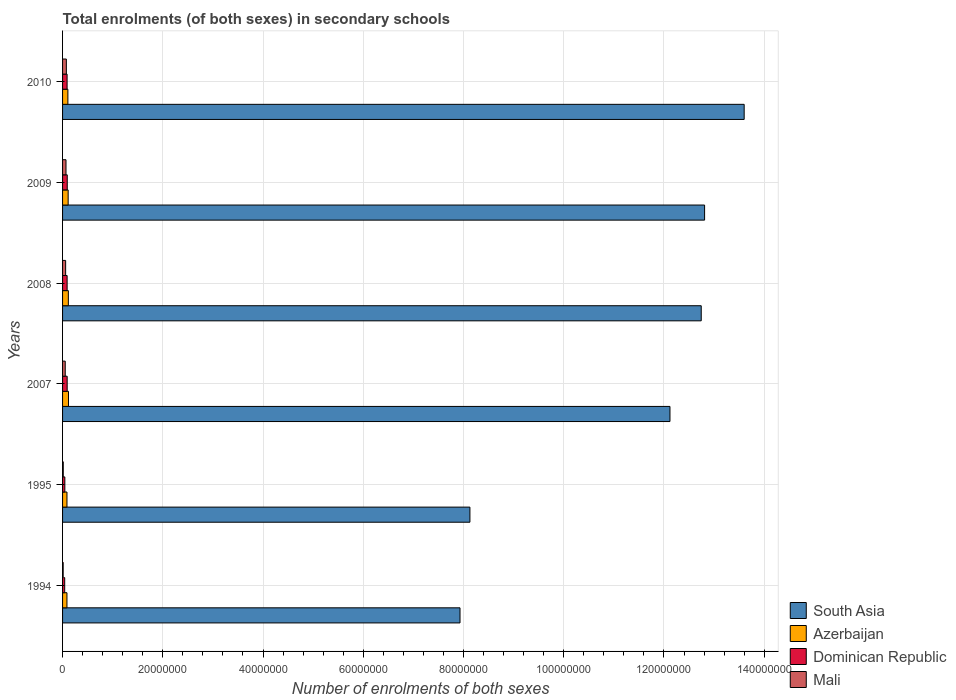Are the number of bars per tick equal to the number of legend labels?
Your response must be concise. Yes. How many bars are there on the 4th tick from the top?
Your answer should be compact. 4. What is the number of enrolments in secondary schools in Dominican Republic in 2009?
Provide a short and direct response. 9.34e+05. Across all years, what is the maximum number of enrolments in secondary schools in Azerbaijan?
Provide a short and direct response. 1.18e+06. Across all years, what is the minimum number of enrolments in secondary schools in South Asia?
Ensure brevity in your answer.  7.93e+07. In which year was the number of enrolments in secondary schools in Azerbaijan maximum?
Your answer should be very brief. 2007. What is the total number of enrolments in secondary schools in South Asia in the graph?
Give a very brief answer. 6.73e+08. What is the difference between the number of enrolments in secondary schools in South Asia in 1994 and that in 2008?
Provide a succinct answer. -4.81e+07. What is the difference between the number of enrolments in secondary schools in Azerbaijan in 2010 and the number of enrolments in secondary schools in South Asia in 2008?
Ensure brevity in your answer.  -1.26e+08. What is the average number of enrolments in secondary schools in South Asia per year?
Provide a succinct answer. 1.12e+08. In the year 1994, what is the difference between the number of enrolments in secondary schools in Azerbaijan and number of enrolments in secondary schools in Dominican Republic?
Ensure brevity in your answer.  4.49e+05. In how many years, is the number of enrolments in secondary schools in Mali greater than 120000000 ?
Provide a succinct answer. 0. What is the ratio of the number of enrolments in secondary schools in Dominican Republic in 1994 to that in 2008?
Provide a short and direct response. 0.47. Is the difference between the number of enrolments in secondary schools in Azerbaijan in 2007 and 2009 greater than the difference between the number of enrolments in secondary schools in Dominican Republic in 2007 and 2009?
Offer a terse response. Yes. What is the difference between the highest and the second highest number of enrolments in secondary schools in Dominican Republic?
Ensure brevity in your answer.  1.36e+04. What is the difference between the highest and the lowest number of enrolments in secondary schools in South Asia?
Offer a terse response. 5.67e+07. In how many years, is the number of enrolments in secondary schools in Dominican Republic greater than the average number of enrolments in secondary schools in Dominican Republic taken over all years?
Provide a short and direct response. 4. What does the 3rd bar from the top in 2009 represents?
Offer a very short reply. Azerbaijan. What does the 1st bar from the bottom in 2007 represents?
Offer a terse response. South Asia. Is it the case that in every year, the sum of the number of enrolments in secondary schools in South Asia and number of enrolments in secondary schools in Azerbaijan is greater than the number of enrolments in secondary schools in Mali?
Keep it short and to the point. Yes. Are all the bars in the graph horizontal?
Provide a short and direct response. Yes. How many years are there in the graph?
Your response must be concise. 6. What is the difference between two consecutive major ticks on the X-axis?
Offer a terse response. 2.00e+07. Are the values on the major ticks of X-axis written in scientific E-notation?
Ensure brevity in your answer.  No. Does the graph contain any zero values?
Make the answer very short. No. Where does the legend appear in the graph?
Ensure brevity in your answer.  Bottom right. What is the title of the graph?
Your answer should be very brief. Total enrolments (of both sexes) in secondary schools. Does "Japan" appear as one of the legend labels in the graph?
Make the answer very short. No. What is the label or title of the X-axis?
Your answer should be very brief. Number of enrolments of both sexes. What is the label or title of the Y-axis?
Provide a succinct answer. Years. What is the Number of enrolments of both sexes of South Asia in 1994?
Ensure brevity in your answer.  7.93e+07. What is the Number of enrolments of both sexes of Azerbaijan in 1994?
Give a very brief answer. 8.74e+05. What is the Number of enrolments of both sexes of Dominican Republic in 1994?
Your response must be concise. 4.25e+05. What is the Number of enrolments of both sexes of Mali in 1994?
Your response must be concise. 1.21e+05. What is the Number of enrolments of both sexes in South Asia in 1995?
Make the answer very short. 8.13e+07. What is the Number of enrolments of both sexes of Azerbaijan in 1995?
Make the answer very short. 8.78e+05. What is the Number of enrolments of both sexes of Dominican Republic in 1995?
Offer a terse response. 4.55e+05. What is the Number of enrolments of both sexes in Mali in 1995?
Offer a terse response. 1.40e+05. What is the Number of enrolments of both sexes of South Asia in 2007?
Offer a terse response. 1.21e+08. What is the Number of enrolments of both sexes in Azerbaijan in 2007?
Make the answer very short. 1.18e+06. What is the Number of enrolments of both sexes in Dominican Republic in 2007?
Keep it short and to the point. 9.20e+05. What is the Number of enrolments of both sexes of Mali in 2007?
Your answer should be very brief. 5.34e+05. What is the Number of enrolments of both sexes of South Asia in 2008?
Provide a succinct answer. 1.27e+08. What is the Number of enrolments of both sexes of Azerbaijan in 2008?
Provide a short and direct response. 1.15e+06. What is the Number of enrolments of both sexes of Dominican Republic in 2008?
Provide a succinct answer. 9.09e+05. What is the Number of enrolments of both sexes of Mali in 2008?
Your answer should be compact. 6.12e+05. What is the Number of enrolments of both sexes in South Asia in 2009?
Make the answer very short. 1.28e+08. What is the Number of enrolments of both sexes of Azerbaijan in 2009?
Provide a short and direct response. 1.11e+06. What is the Number of enrolments of both sexes in Dominican Republic in 2009?
Offer a very short reply. 9.34e+05. What is the Number of enrolments of both sexes of Mali in 2009?
Give a very brief answer. 6.86e+05. What is the Number of enrolments of both sexes in South Asia in 2010?
Provide a succinct answer. 1.36e+08. What is the Number of enrolments of both sexes of Azerbaijan in 2010?
Your response must be concise. 1.06e+06. What is the Number of enrolments of both sexes in Dominican Republic in 2010?
Offer a terse response. 9.05e+05. What is the Number of enrolments of both sexes of Mali in 2010?
Make the answer very short. 7.58e+05. Across all years, what is the maximum Number of enrolments of both sexes in South Asia?
Offer a very short reply. 1.36e+08. Across all years, what is the maximum Number of enrolments of both sexes of Azerbaijan?
Ensure brevity in your answer.  1.18e+06. Across all years, what is the maximum Number of enrolments of both sexes in Dominican Republic?
Give a very brief answer. 9.34e+05. Across all years, what is the maximum Number of enrolments of both sexes of Mali?
Provide a succinct answer. 7.58e+05. Across all years, what is the minimum Number of enrolments of both sexes in South Asia?
Give a very brief answer. 7.93e+07. Across all years, what is the minimum Number of enrolments of both sexes in Azerbaijan?
Keep it short and to the point. 8.74e+05. Across all years, what is the minimum Number of enrolments of both sexes in Dominican Republic?
Offer a very short reply. 4.25e+05. Across all years, what is the minimum Number of enrolments of both sexes of Mali?
Your answer should be compact. 1.21e+05. What is the total Number of enrolments of both sexes in South Asia in the graph?
Provide a succinct answer. 6.73e+08. What is the total Number of enrolments of both sexes in Azerbaijan in the graph?
Make the answer very short. 6.26e+06. What is the total Number of enrolments of both sexes of Dominican Republic in the graph?
Offer a very short reply. 4.55e+06. What is the total Number of enrolments of both sexes of Mali in the graph?
Provide a short and direct response. 2.85e+06. What is the difference between the Number of enrolments of both sexes of South Asia in 1994 and that in 1995?
Offer a terse response. -1.98e+06. What is the difference between the Number of enrolments of both sexes of Azerbaijan in 1994 and that in 1995?
Offer a terse response. -3873. What is the difference between the Number of enrolments of both sexes in Dominican Republic in 1994 and that in 1995?
Keep it short and to the point. -2.93e+04. What is the difference between the Number of enrolments of both sexes of Mali in 1994 and that in 1995?
Provide a succinct answer. -1.89e+04. What is the difference between the Number of enrolments of both sexes of South Asia in 1994 and that in 2007?
Ensure brevity in your answer.  -4.19e+07. What is the difference between the Number of enrolments of both sexes of Azerbaijan in 1994 and that in 2007?
Give a very brief answer. -3.07e+05. What is the difference between the Number of enrolments of both sexes in Dominican Republic in 1994 and that in 2007?
Make the answer very short. -4.95e+05. What is the difference between the Number of enrolments of both sexes in Mali in 1994 and that in 2007?
Your answer should be very brief. -4.13e+05. What is the difference between the Number of enrolments of both sexes of South Asia in 1994 and that in 2008?
Give a very brief answer. -4.81e+07. What is the difference between the Number of enrolments of both sexes of Azerbaijan in 1994 and that in 2008?
Ensure brevity in your answer.  -2.77e+05. What is the difference between the Number of enrolments of both sexes in Dominican Republic in 1994 and that in 2008?
Your answer should be very brief. -4.84e+05. What is the difference between the Number of enrolments of both sexes of Mali in 1994 and that in 2008?
Keep it short and to the point. -4.91e+05. What is the difference between the Number of enrolments of both sexes in South Asia in 1994 and that in 2009?
Keep it short and to the point. -4.88e+07. What is the difference between the Number of enrolments of both sexes of Azerbaijan in 1994 and that in 2009?
Your answer should be very brief. -2.40e+05. What is the difference between the Number of enrolments of both sexes of Dominican Republic in 1994 and that in 2009?
Offer a terse response. -5.09e+05. What is the difference between the Number of enrolments of both sexes in Mali in 1994 and that in 2009?
Keep it short and to the point. -5.65e+05. What is the difference between the Number of enrolments of both sexes in South Asia in 1994 and that in 2010?
Ensure brevity in your answer.  -5.67e+07. What is the difference between the Number of enrolments of both sexes of Azerbaijan in 1994 and that in 2010?
Make the answer very short. -1.89e+05. What is the difference between the Number of enrolments of both sexes of Dominican Republic in 1994 and that in 2010?
Your response must be concise. -4.79e+05. What is the difference between the Number of enrolments of both sexes in Mali in 1994 and that in 2010?
Your response must be concise. -6.37e+05. What is the difference between the Number of enrolments of both sexes in South Asia in 1995 and that in 2007?
Your answer should be compact. -3.99e+07. What is the difference between the Number of enrolments of both sexes of Azerbaijan in 1995 and that in 2007?
Your response must be concise. -3.04e+05. What is the difference between the Number of enrolments of both sexes in Dominican Republic in 1995 and that in 2007?
Ensure brevity in your answer.  -4.66e+05. What is the difference between the Number of enrolments of both sexes in Mali in 1995 and that in 2007?
Keep it short and to the point. -3.94e+05. What is the difference between the Number of enrolments of both sexes in South Asia in 1995 and that in 2008?
Your response must be concise. -4.62e+07. What is the difference between the Number of enrolments of both sexes in Azerbaijan in 1995 and that in 2008?
Make the answer very short. -2.74e+05. What is the difference between the Number of enrolments of both sexes in Dominican Republic in 1995 and that in 2008?
Ensure brevity in your answer.  -4.55e+05. What is the difference between the Number of enrolments of both sexes in Mali in 1995 and that in 2008?
Make the answer very short. -4.72e+05. What is the difference between the Number of enrolments of both sexes of South Asia in 1995 and that in 2009?
Your answer should be compact. -4.68e+07. What is the difference between the Number of enrolments of both sexes in Azerbaijan in 1995 and that in 2009?
Your response must be concise. -2.37e+05. What is the difference between the Number of enrolments of both sexes in Dominican Republic in 1995 and that in 2009?
Your answer should be very brief. -4.80e+05. What is the difference between the Number of enrolments of both sexes in Mali in 1995 and that in 2009?
Your answer should be compact. -5.46e+05. What is the difference between the Number of enrolments of both sexes in South Asia in 1995 and that in 2010?
Your answer should be very brief. -5.47e+07. What is the difference between the Number of enrolments of both sexes in Azerbaijan in 1995 and that in 2010?
Offer a terse response. -1.85e+05. What is the difference between the Number of enrolments of both sexes of Dominican Republic in 1995 and that in 2010?
Ensure brevity in your answer.  -4.50e+05. What is the difference between the Number of enrolments of both sexes of Mali in 1995 and that in 2010?
Ensure brevity in your answer.  -6.19e+05. What is the difference between the Number of enrolments of both sexes of South Asia in 2007 and that in 2008?
Keep it short and to the point. -6.24e+06. What is the difference between the Number of enrolments of both sexes of Azerbaijan in 2007 and that in 2008?
Your answer should be very brief. 3.00e+04. What is the difference between the Number of enrolments of both sexes in Dominican Republic in 2007 and that in 2008?
Your response must be concise. 1.12e+04. What is the difference between the Number of enrolments of both sexes in Mali in 2007 and that in 2008?
Make the answer very short. -7.82e+04. What is the difference between the Number of enrolments of both sexes in South Asia in 2007 and that in 2009?
Your answer should be compact. -6.91e+06. What is the difference between the Number of enrolments of both sexes of Azerbaijan in 2007 and that in 2009?
Your response must be concise. 6.70e+04. What is the difference between the Number of enrolments of both sexes of Dominican Republic in 2007 and that in 2009?
Make the answer very short. -1.36e+04. What is the difference between the Number of enrolments of both sexes in Mali in 2007 and that in 2009?
Keep it short and to the point. -1.52e+05. What is the difference between the Number of enrolments of both sexes in South Asia in 2007 and that in 2010?
Make the answer very short. -1.48e+07. What is the difference between the Number of enrolments of both sexes in Azerbaijan in 2007 and that in 2010?
Give a very brief answer. 1.19e+05. What is the difference between the Number of enrolments of both sexes in Dominican Republic in 2007 and that in 2010?
Your response must be concise. 1.60e+04. What is the difference between the Number of enrolments of both sexes in Mali in 2007 and that in 2010?
Give a very brief answer. -2.24e+05. What is the difference between the Number of enrolments of both sexes in South Asia in 2008 and that in 2009?
Keep it short and to the point. -6.70e+05. What is the difference between the Number of enrolments of both sexes in Azerbaijan in 2008 and that in 2009?
Ensure brevity in your answer.  3.70e+04. What is the difference between the Number of enrolments of both sexes of Dominican Republic in 2008 and that in 2009?
Keep it short and to the point. -2.48e+04. What is the difference between the Number of enrolments of both sexes of Mali in 2008 and that in 2009?
Give a very brief answer. -7.41e+04. What is the difference between the Number of enrolments of both sexes of South Asia in 2008 and that in 2010?
Make the answer very short. -8.57e+06. What is the difference between the Number of enrolments of both sexes of Azerbaijan in 2008 and that in 2010?
Give a very brief answer. 8.87e+04. What is the difference between the Number of enrolments of both sexes in Dominican Republic in 2008 and that in 2010?
Offer a very short reply. 4804. What is the difference between the Number of enrolments of both sexes of Mali in 2008 and that in 2010?
Your response must be concise. -1.46e+05. What is the difference between the Number of enrolments of both sexes in South Asia in 2009 and that in 2010?
Your answer should be compact. -7.90e+06. What is the difference between the Number of enrolments of both sexes in Azerbaijan in 2009 and that in 2010?
Your answer should be compact. 5.17e+04. What is the difference between the Number of enrolments of both sexes in Dominican Republic in 2009 and that in 2010?
Provide a succinct answer. 2.96e+04. What is the difference between the Number of enrolments of both sexes in Mali in 2009 and that in 2010?
Offer a terse response. -7.22e+04. What is the difference between the Number of enrolments of both sexes in South Asia in 1994 and the Number of enrolments of both sexes in Azerbaijan in 1995?
Your answer should be very brief. 7.84e+07. What is the difference between the Number of enrolments of both sexes of South Asia in 1994 and the Number of enrolments of both sexes of Dominican Republic in 1995?
Your answer should be compact. 7.88e+07. What is the difference between the Number of enrolments of both sexes of South Asia in 1994 and the Number of enrolments of both sexes of Mali in 1995?
Offer a terse response. 7.92e+07. What is the difference between the Number of enrolments of both sexes of Azerbaijan in 1994 and the Number of enrolments of both sexes of Dominican Republic in 1995?
Offer a terse response. 4.19e+05. What is the difference between the Number of enrolments of both sexes of Azerbaijan in 1994 and the Number of enrolments of both sexes of Mali in 1995?
Keep it short and to the point. 7.34e+05. What is the difference between the Number of enrolments of both sexes of Dominican Republic in 1994 and the Number of enrolments of both sexes of Mali in 1995?
Ensure brevity in your answer.  2.85e+05. What is the difference between the Number of enrolments of both sexes of South Asia in 1994 and the Number of enrolments of both sexes of Azerbaijan in 2007?
Your answer should be compact. 7.81e+07. What is the difference between the Number of enrolments of both sexes in South Asia in 1994 and the Number of enrolments of both sexes in Dominican Republic in 2007?
Give a very brief answer. 7.84e+07. What is the difference between the Number of enrolments of both sexes in South Asia in 1994 and the Number of enrolments of both sexes in Mali in 2007?
Keep it short and to the point. 7.88e+07. What is the difference between the Number of enrolments of both sexes of Azerbaijan in 1994 and the Number of enrolments of both sexes of Dominican Republic in 2007?
Your answer should be very brief. -4.66e+04. What is the difference between the Number of enrolments of both sexes in Azerbaijan in 1994 and the Number of enrolments of both sexes in Mali in 2007?
Your answer should be compact. 3.40e+05. What is the difference between the Number of enrolments of both sexes in Dominican Republic in 1994 and the Number of enrolments of both sexes in Mali in 2007?
Ensure brevity in your answer.  -1.09e+05. What is the difference between the Number of enrolments of both sexes in South Asia in 1994 and the Number of enrolments of both sexes in Azerbaijan in 2008?
Your answer should be compact. 7.82e+07. What is the difference between the Number of enrolments of both sexes of South Asia in 1994 and the Number of enrolments of both sexes of Dominican Republic in 2008?
Your answer should be very brief. 7.84e+07. What is the difference between the Number of enrolments of both sexes in South Asia in 1994 and the Number of enrolments of both sexes in Mali in 2008?
Your response must be concise. 7.87e+07. What is the difference between the Number of enrolments of both sexes of Azerbaijan in 1994 and the Number of enrolments of both sexes of Dominican Republic in 2008?
Provide a succinct answer. -3.54e+04. What is the difference between the Number of enrolments of both sexes in Azerbaijan in 1994 and the Number of enrolments of both sexes in Mali in 2008?
Your answer should be compact. 2.62e+05. What is the difference between the Number of enrolments of both sexes of Dominican Republic in 1994 and the Number of enrolments of both sexes of Mali in 2008?
Ensure brevity in your answer.  -1.87e+05. What is the difference between the Number of enrolments of both sexes of South Asia in 1994 and the Number of enrolments of both sexes of Azerbaijan in 2009?
Provide a short and direct response. 7.82e+07. What is the difference between the Number of enrolments of both sexes of South Asia in 1994 and the Number of enrolments of both sexes of Dominican Republic in 2009?
Keep it short and to the point. 7.84e+07. What is the difference between the Number of enrolments of both sexes of South Asia in 1994 and the Number of enrolments of both sexes of Mali in 2009?
Your answer should be compact. 7.86e+07. What is the difference between the Number of enrolments of both sexes in Azerbaijan in 1994 and the Number of enrolments of both sexes in Dominican Republic in 2009?
Your answer should be compact. -6.02e+04. What is the difference between the Number of enrolments of both sexes in Azerbaijan in 1994 and the Number of enrolments of both sexes in Mali in 2009?
Your response must be concise. 1.88e+05. What is the difference between the Number of enrolments of both sexes in Dominican Republic in 1994 and the Number of enrolments of both sexes in Mali in 2009?
Keep it short and to the point. -2.61e+05. What is the difference between the Number of enrolments of both sexes in South Asia in 1994 and the Number of enrolments of both sexes in Azerbaijan in 2010?
Keep it short and to the point. 7.82e+07. What is the difference between the Number of enrolments of both sexes in South Asia in 1994 and the Number of enrolments of both sexes in Dominican Republic in 2010?
Offer a very short reply. 7.84e+07. What is the difference between the Number of enrolments of both sexes in South Asia in 1994 and the Number of enrolments of both sexes in Mali in 2010?
Ensure brevity in your answer.  7.85e+07. What is the difference between the Number of enrolments of both sexes in Azerbaijan in 1994 and the Number of enrolments of both sexes in Dominican Republic in 2010?
Keep it short and to the point. -3.06e+04. What is the difference between the Number of enrolments of both sexes in Azerbaijan in 1994 and the Number of enrolments of both sexes in Mali in 2010?
Offer a very short reply. 1.16e+05. What is the difference between the Number of enrolments of both sexes of Dominican Republic in 1994 and the Number of enrolments of both sexes of Mali in 2010?
Keep it short and to the point. -3.33e+05. What is the difference between the Number of enrolments of both sexes in South Asia in 1995 and the Number of enrolments of both sexes in Azerbaijan in 2007?
Your answer should be compact. 8.01e+07. What is the difference between the Number of enrolments of both sexes in South Asia in 1995 and the Number of enrolments of both sexes in Dominican Republic in 2007?
Your answer should be compact. 8.04e+07. What is the difference between the Number of enrolments of both sexes in South Asia in 1995 and the Number of enrolments of both sexes in Mali in 2007?
Make the answer very short. 8.07e+07. What is the difference between the Number of enrolments of both sexes in Azerbaijan in 1995 and the Number of enrolments of both sexes in Dominican Republic in 2007?
Provide a succinct answer. -4.27e+04. What is the difference between the Number of enrolments of both sexes in Azerbaijan in 1995 and the Number of enrolments of both sexes in Mali in 2007?
Your answer should be very brief. 3.44e+05. What is the difference between the Number of enrolments of both sexes of Dominican Republic in 1995 and the Number of enrolments of both sexes of Mali in 2007?
Ensure brevity in your answer.  -7.93e+04. What is the difference between the Number of enrolments of both sexes of South Asia in 1995 and the Number of enrolments of both sexes of Azerbaijan in 2008?
Your answer should be very brief. 8.01e+07. What is the difference between the Number of enrolments of both sexes in South Asia in 1995 and the Number of enrolments of both sexes in Dominican Republic in 2008?
Offer a terse response. 8.04e+07. What is the difference between the Number of enrolments of both sexes in South Asia in 1995 and the Number of enrolments of both sexes in Mali in 2008?
Offer a very short reply. 8.07e+07. What is the difference between the Number of enrolments of both sexes of Azerbaijan in 1995 and the Number of enrolments of both sexes of Dominican Republic in 2008?
Make the answer very short. -3.15e+04. What is the difference between the Number of enrolments of both sexes of Azerbaijan in 1995 and the Number of enrolments of both sexes of Mali in 2008?
Your answer should be compact. 2.66e+05. What is the difference between the Number of enrolments of both sexes of Dominican Republic in 1995 and the Number of enrolments of both sexes of Mali in 2008?
Your answer should be very brief. -1.57e+05. What is the difference between the Number of enrolments of both sexes in South Asia in 1995 and the Number of enrolments of both sexes in Azerbaijan in 2009?
Keep it short and to the point. 8.02e+07. What is the difference between the Number of enrolments of both sexes in South Asia in 1995 and the Number of enrolments of both sexes in Dominican Republic in 2009?
Ensure brevity in your answer.  8.03e+07. What is the difference between the Number of enrolments of both sexes in South Asia in 1995 and the Number of enrolments of both sexes in Mali in 2009?
Make the answer very short. 8.06e+07. What is the difference between the Number of enrolments of both sexes of Azerbaijan in 1995 and the Number of enrolments of both sexes of Dominican Republic in 2009?
Your answer should be compact. -5.63e+04. What is the difference between the Number of enrolments of both sexes of Azerbaijan in 1995 and the Number of enrolments of both sexes of Mali in 2009?
Ensure brevity in your answer.  1.92e+05. What is the difference between the Number of enrolments of both sexes of Dominican Republic in 1995 and the Number of enrolments of both sexes of Mali in 2009?
Your response must be concise. -2.32e+05. What is the difference between the Number of enrolments of both sexes of South Asia in 1995 and the Number of enrolments of both sexes of Azerbaijan in 2010?
Provide a short and direct response. 8.02e+07. What is the difference between the Number of enrolments of both sexes of South Asia in 1995 and the Number of enrolments of both sexes of Dominican Republic in 2010?
Make the answer very short. 8.04e+07. What is the difference between the Number of enrolments of both sexes of South Asia in 1995 and the Number of enrolments of both sexes of Mali in 2010?
Keep it short and to the point. 8.05e+07. What is the difference between the Number of enrolments of both sexes of Azerbaijan in 1995 and the Number of enrolments of both sexes of Dominican Republic in 2010?
Offer a very short reply. -2.67e+04. What is the difference between the Number of enrolments of both sexes in Azerbaijan in 1995 and the Number of enrolments of both sexes in Mali in 2010?
Your response must be concise. 1.20e+05. What is the difference between the Number of enrolments of both sexes in Dominican Republic in 1995 and the Number of enrolments of both sexes in Mali in 2010?
Your response must be concise. -3.04e+05. What is the difference between the Number of enrolments of both sexes of South Asia in 2007 and the Number of enrolments of both sexes of Azerbaijan in 2008?
Ensure brevity in your answer.  1.20e+08. What is the difference between the Number of enrolments of both sexes in South Asia in 2007 and the Number of enrolments of both sexes in Dominican Republic in 2008?
Your answer should be very brief. 1.20e+08. What is the difference between the Number of enrolments of both sexes in South Asia in 2007 and the Number of enrolments of both sexes in Mali in 2008?
Offer a terse response. 1.21e+08. What is the difference between the Number of enrolments of both sexes of Azerbaijan in 2007 and the Number of enrolments of both sexes of Dominican Republic in 2008?
Provide a short and direct response. 2.72e+05. What is the difference between the Number of enrolments of both sexes in Azerbaijan in 2007 and the Number of enrolments of both sexes in Mali in 2008?
Provide a short and direct response. 5.69e+05. What is the difference between the Number of enrolments of both sexes of Dominican Republic in 2007 and the Number of enrolments of both sexes of Mali in 2008?
Offer a terse response. 3.08e+05. What is the difference between the Number of enrolments of both sexes of South Asia in 2007 and the Number of enrolments of both sexes of Azerbaijan in 2009?
Offer a terse response. 1.20e+08. What is the difference between the Number of enrolments of both sexes of South Asia in 2007 and the Number of enrolments of both sexes of Dominican Republic in 2009?
Give a very brief answer. 1.20e+08. What is the difference between the Number of enrolments of both sexes of South Asia in 2007 and the Number of enrolments of both sexes of Mali in 2009?
Provide a short and direct response. 1.21e+08. What is the difference between the Number of enrolments of both sexes in Azerbaijan in 2007 and the Number of enrolments of both sexes in Dominican Republic in 2009?
Keep it short and to the point. 2.47e+05. What is the difference between the Number of enrolments of both sexes of Azerbaijan in 2007 and the Number of enrolments of both sexes of Mali in 2009?
Provide a succinct answer. 4.95e+05. What is the difference between the Number of enrolments of both sexes in Dominican Republic in 2007 and the Number of enrolments of both sexes in Mali in 2009?
Your answer should be compact. 2.34e+05. What is the difference between the Number of enrolments of both sexes of South Asia in 2007 and the Number of enrolments of both sexes of Azerbaijan in 2010?
Give a very brief answer. 1.20e+08. What is the difference between the Number of enrolments of both sexes in South Asia in 2007 and the Number of enrolments of both sexes in Dominican Republic in 2010?
Keep it short and to the point. 1.20e+08. What is the difference between the Number of enrolments of both sexes in South Asia in 2007 and the Number of enrolments of both sexes in Mali in 2010?
Your answer should be compact. 1.20e+08. What is the difference between the Number of enrolments of both sexes in Azerbaijan in 2007 and the Number of enrolments of both sexes in Dominican Republic in 2010?
Offer a very short reply. 2.77e+05. What is the difference between the Number of enrolments of both sexes of Azerbaijan in 2007 and the Number of enrolments of both sexes of Mali in 2010?
Keep it short and to the point. 4.23e+05. What is the difference between the Number of enrolments of both sexes in Dominican Republic in 2007 and the Number of enrolments of both sexes in Mali in 2010?
Your response must be concise. 1.62e+05. What is the difference between the Number of enrolments of both sexes in South Asia in 2008 and the Number of enrolments of both sexes in Azerbaijan in 2009?
Give a very brief answer. 1.26e+08. What is the difference between the Number of enrolments of both sexes in South Asia in 2008 and the Number of enrolments of both sexes in Dominican Republic in 2009?
Your answer should be compact. 1.27e+08. What is the difference between the Number of enrolments of both sexes of South Asia in 2008 and the Number of enrolments of both sexes of Mali in 2009?
Your response must be concise. 1.27e+08. What is the difference between the Number of enrolments of both sexes of Azerbaijan in 2008 and the Number of enrolments of both sexes of Dominican Republic in 2009?
Give a very brief answer. 2.17e+05. What is the difference between the Number of enrolments of both sexes of Azerbaijan in 2008 and the Number of enrolments of both sexes of Mali in 2009?
Provide a short and direct response. 4.65e+05. What is the difference between the Number of enrolments of both sexes in Dominican Republic in 2008 and the Number of enrolments of both sexes in Mali in 2009?
Provide a short and direct response. 2.23e+05. What is the difference between the Number of enrolments of both sexes in South Asia in 2008 and the Number of enrolments of both sexes in Azerbaijan in 2010?
Your answer should be very brief. 1.26e+08. What is the difference between the Number of enrolments of both sexes in South Asia in 2008 and the Number of enrolments of both sexes in Dominican Republic in 2010?
Make the answer very short. 1.27e+08. What is the difference between the Number of enrolments of both sexes of South Asia in 2008 and the Number of enrolments of both sexes of Mali in 2010?
Your answer should be very brief. 1.27e+08. What is the difference between the Number of enrolments of both sexes in Azerbaijan in 2008 and the Number of enrolments of both sexes in Dominican Republic in 2010?
Keep it short and to the point. 2.47e+05. What is the difference between the Number of enrolments of both sexes in Azerbaijan in 2008 and the Number of enrolments of both sexes in Mali in 2010?
Your response must be concise. 3.93e+05. What is the difference between the Number of enrolments of both sexes of Dominican Republic in 2008 and the Number of enrolments of both sexes of Mali in 2010?
Your response must be concise. 1.51e+05. What is the difference between the Number of enrolments of both sexes in South Asia in 2009 and the Number of enrolments of both sexes in Azerbaijan in 2010?
Offer a terse response. 1.27e+08. What is the difference between the Number of enrolments of both sexes in South Asia in 2009 and the Number of enrolments of both sexes in Dominican Republic in 2010?
Offer a terse response. 1.27e+08. What is the difference between the Number of enrolments of both sexes in South Asia in 2009 and the Number of enrolments of both sexes in Mali in 2010?
Provide a succinct answer. 1.27e+08. What is the difference between the Number of enrolments of both sexes in Azerbaijan in 2009 and the Number of enrolments of both sexes in Dominican Republic in 2010?
Your response must be concise. 2.10e+05. What is the difference between the Number of enrolments of both sexes of Azerbaijan in 2009 and the Number of enrolments of both sexes of Mali in 2010?
Your answer should be compact. 3.56e+05. What is the difference between the Number of enrolments of both sexes of Dominican Republic in 2009 and the Number of enrolments of both sexes of Mali in 2010?
Give a very brief answer. 1.76e+05. What is the average Number of enrolments of both sexes of South Asia per year?
Your answer should be very brief. 1.12e+08. What is the average Number of enrolments of both sexes in Azerbaijan per year?
Ensure brevity in your answer.  1.04e+06. What is the average Number of enrolments of both sexes in Dominican Republic per year?
Provide a short and direct response. 7.58e+05. What is the average Number of enrolments of both sexes in Mali per year?
Keep it short and to the point. 4.75e+05. In the year 1994, what is the difference between the Number of enrolments of both sexes in South Asia and Number of enrolments of both sexes in Azerbaijan?
Ensure brevity in your answer.  7.84e+07. In the year 1994, what is the difference between the Number of enrolments of both sexes of South Asia and Number of enrolments of both sexes of Dominican Republic?
Make the answer very short. 7.89e+07. In the year 1994, what is the difference between the Number of enrolments of both sexes in South Asia and Number of enrolments of both sexes in Mali?
Keep it short and to the point. 7.92e+07. In the year 1994, what is the difference between the Number of enrolments of both sexes in Azerbaijan and Number of enrolments of both sexes in Dominican Republic?
Provide a short and direct response. 4.49e+05. In the year 1994, what is the difference between the Number of enrolments of both sexes of Azerbaijan and Number of enrolments of both sexes of Mali?
Ensure brevity in your answer.  7.53e+05. In the year 1994, what is the difference between the Number of enrolments of both sexes in Dominican Republic and Number of enrolments of both sexes in Mali?
Make the answer very short. 3.04e+05. In the year 1995, what is the difference between the Number of enrolments of both sexes of South Asia and Number of enrolments of both sexes of Azerbaijan?
Provide a succinct answer. 8.04e+07. In the year 1995, what is the difference between the Number of enrolments of both sexes in South Asia and Number of enrolments of both sexes in Dominican Republic?
Provide a succinct answer. 8.08e+07. In the year 1995, what is the difference between the Number of enrolments of both sexes in South Asia and Number of enrolments of both sexes in Mali?
Keep it short and to the point. 8.11e+07. In the year 1995, what is the difference between the Number of enrolments of both sexes in Azerbaijan and Number of enrolments of both sexes in Dominican Republic?
Your response must be concise. 4.23e+05. In the year 1995, what is the difference between the Number of enrolments of both sexes in Azerbaijan and Number of enrolments of both sexes in Mali?
Provide a short and direct response. 7.38e+05. In the year 1995, what is the difference between the Number of enrolments of both sexes in Dominican Republic and Number of enrolments of both sexes in Mali?
Your answer should be compact. 3.15e+05. In the year 2007, what is the difference between the Number of enrolments of both sexes of South Asia and Number of enrolments of both sexes of Azerbaijan?
Keep it short and to the point. 1.20e+08. In the year 2007, what is the difference between the Number of enrolments of both sexes in South Asia and Number of enrolments of both sexes in Dominican Republic?
Your answer should be compact. 1.20e+08. In the year 2007, what is the difference between the Number of enrolments of both sexes in South Asia and Number of enrolments of both sexes in Mali?
Your response must be concise. 1.21e+08. In the year 2007, what is the difference between the Number of enrolments of both sexes in Azerbaijan and Number of enrolments of both sexes in Dominican Republic?
Provide a succinct answer. 2.61e+05. In the year 2007, what is the difference between the Number of enrolments of both sexes in Azerbaijan and Number of enrolments of both sexes in Mali?
Offer a very short reply. 6.47e+05. In the year 2007, what is the difference between the Number of enrolments of both sexes in Dominican Republic and Number of enrolments of both sexes in Mali?
Your answer should be very brief. 3.87e+05. In the year 2008, what is the difference between the Number of enrolments of both sexes of South Asia and Number of enrolments of both sexes of Azerbaijan?
Provide a short and direct response. 1.26e+08. In the year 2008, what is the difference between the Number of enrolments of both sexes of South Asia and Number of enrolments of both sexes of Dominican Republic?
Give a very brief answer. 1.27e+08. In the year 2008, what is the difference between the Number of enrolments of both sexes of South Asia and Number of enrolments of both sexes of Mali?
Your answer should be compact. 1.27e+08. In the year 2008, what is the difference between the Number of enrolments of both sexes in Azerbaijan and Number of enrolments of both sexes in Dominican Republic?
Make the answer very short. 2.42e+05. In the year 2008, what is the difference between the Number of enrolments of both sexes in Azerbaijan and Number of enrolments of both sexes in Mali?
Offer a very short reply. 5.39e+05. In the year 2008, what is the difference between the Number of enrolments of both sexes of Dominican Republic and Number of enrolments of both sexes of Mali?
Provide a short and direct response. 2.97e+05. In the year 2009, what is the difference between the Number of enrolments of both sexes of South Asia and Number of enrolments of both sexes of Azerbaijan?
Provide a short and direct response. 1.27e+08. In the year 2009, what is the difference between the Number of enrolments of both sexes in South Asia and Number of enrolments of both sexes in Dominican Republic?
Provide a succinct answer. 1.27e+08. In the year 2009, what is the difference between the Number of enrolments of both sexes of South Asia and Number of enrolments of both sexes of Mali?
Give a very brief answer. 1.27e+08. In the year 2009, what is the difference between the Number of enrolments of both sexes in Azerbaijan and Number of enrolments of both sexes in Dominican Republic?
Keep it short and to the point. 1.80e+05. In the year 2009, what is the difference between the Number of enrolments of both sexes in Azerbaijan and Number of enrolments of both sexes in Mali?
Provide a succinct answer. 4.28e+05. In the year 2009, what is the difference between the Number of enrolments of both sexes in Dominican Republic and Number of enrolments of both sexes in Mali?
Keep it short and to the point. 2.48e+05. In the year 2010, what is the difference between the Number of enrolments of both sexes of South Asia and Number of enrolments of both sexes of Azerbaijan?
Make the answer very short. 1.35e+08. In the year 2010, what is the difference between the Number of enrolments of both sexes in South Asia and Number of enrolments of both sexes in Dominican Republic?
Your answer should be compact. 1.35e+08. In the year 2010, what is the difference between the Number of enrolments of both sexes of South Asia and Number of enrolments of both sexes of Mali?
Offer a terse response. 1.35e+08. In the year 2010, what is the difference between the Number of enrolments of both sexes in Azerbaijan and Number of enrolments of both sexes in Dominican Republic?
Your answer should be very brief. 1.58e+05. In the year 2010, what is the difference between the Number of enrolments of both sexes of Azerbaijan and Number of enrolments of both sexes of Mali?
Your response must be concise. 3.04e+05. In the year 2010, what is the difference between the Number of enrolments of both sexes of Dominican Republic and Number of enrolments of both sexes of Mali?
Keep it short and to the point. 1.46e+05. What is the ratio of the Number of enrolments of both sexes in South Asia in 1994 to that in 1995?
Your response must be concise. 0.98. What is the ratio of the Number of enrolments of both sexes of Dominican Republic in 1994 to that in 1995?
Give a very brief answer. 0.94. What is the ratio of the Number of enrolments of both sexes of Mali in 1994 to that in 1995?
Offer a very short reply. 0.86. What is the ratio of the Number of enrolments of both sexes of South Asia in 1994 to that in 2007?
Your response must be concise. 0.65. What is the ratio of the Number of enrolments of both sexes of Azerbaijan in 1994 to that in 2007?
Provide a short and direct response. 0.74. What is the ratio of the Number of enrolments of both sexes in Dominican Republic in 1994 to that in 2007?
Give a very brief answer. 0.46. What is the ratio of the Number of enrolments of both sexes of Mali in 1994 to that in 2007?
Your answer should be very brief. 0.23. What is the ratio of the Number of enrolments of both sexes in South Asia in 1994 to that in 2008?
Ensure brevity in your answer.  0.62. What is the ratio of the Number of enrolments of both sexes in Azerbaijan in 1994 to that in 2008?
Provide a short and direct response. 0.76. What is the ratio of the Number of enrolments of both sexes of Dominican Republic in 1994 to that in 2008?
Give a very brief answer. 0.47. What is the ratio of the Number of enrolments of both sexes of Mali in 1994 to that in 2008?
Your response must be concise. 0.2. What is the ratio of the Number of enrolments of both sexes of South Asia in 1994 to that in 2009?
Provide a short and direct response. 0.62. What is the ratio of the Number of enrolments of both sexes in Azerbaijan in 1994 to that in 2009?
Give a very brief answer. 0.78. What is the ratio of the Number of enrolments of both sexes in Dominican Republic in 1994 to that in 2009?
Provide a short and direct response. 0.46. What is the ratio of the Number of enrolments of both sexes of Mali in 1994 to that in 2009?
Give a very brief answer. 0.18. What is the ratio of the Number of enrolments of both sexes in South Asia in 1994 to that in 2010?
Provide a succinct answer. 0.58. What is the ratio of the Number of enrolments of both sexes of Azerbaijan in 1994 to that in 2010?
Your answer should be compact. 0.82. What is the ratio of the Number of enrolments of both sexes in Dominican Republic in 1994 to that in 2010?
Provide a short and direct response. 0.47. What is the ratio of the Number of enrolments of both sexes in Mali in 1994 to that in 2010?
Your response must be concise. 0.16. What is the ratio of the Number of enrolments of both sexes of South Asia in 1995 to that in 2007?
Provide a short and direct response. 0.67. What is the ratio of the Number of enrolments of both sexes in Azerbaijan in 1995 to that in 2007?
Offer a terse response. 0.74. What is the ratio of the Number of enrolments of both sexes of Dominican Republic in 1995 to that in 2007?
Your response must be concise. 0.49. What is the ratio of the Number of enrolments of both sexes of Mali in 1995 to that in 2007?
Your answer should be very brief. 0.26. What is the ratio of the Number of enrolments of both sexes in South Asia in 1995 to that in 2008?
Provide a succinct answer. 0.64. What is the ratio of the Number of enrolments of both sexes of Azerbaijan in 1995 to that in 2008?
Give a very brief answer. 0.76. What is the ratio of the Number of enrolments of both sexes of Dominican Republic in 1995 to that in 2008?
Your answer should be very brief. 0.5. What is the ratio of the Number of enrolments of both sexes of Mali in 1995 to that in 2008?
Offer a terse response. 0.23. What is the ratio of the Number of enrolments of both sexes of South Asia in 1995 to that in 2009?
Keep it short and to the point. 0.63. What is the ratio of the Number of enrolments of both sexes of Azerbaijan in 1995 to that in 2009?
Ensure brevity in your answer.  0.79. What is the ratio of the Number of enrolments of both sexes of Dominican Republic in 1995 to that in 2009?
Provide a succinct answer. 0.49. What is the ratio of the Number of enrolments of both sexes in Mali in 1995 to that in 2009?
Provide a short and direct response. 0.2. What is the ratio of the Number of enrolments of both sexes of South Asia in 1995 to that in 2010?
Offer a terse response. 0.6. What is the ratio of the Number of enrolments of both sexes in Azerbaijan in 1995 to that in 2010?
Offer a very short reply. 0.83. What is the ratio of the Number of enrolments of both sexes of Dominican Republic in 1995 to that in 2010?
Give a very brief answer. 0.5. What is the ratio of the Number of enrolments of both sexes of Mali in 1995 to that in 2010?
Provide a short and direct response. 0.18. What is the ratio of the Number of enrolments of both sexes in South Asia in 2007 to that in 2008?
Your answer should be very brief. 0.95. What is the ratio of the Number of enrolments of both sexes in Dominican Republic in 2007 to that in 2008?
Your answer should be very brief. 1.01. What is the ratio of the Number of enrolments of both sexes of Mali in 2007 to that in 2008?
Ensure brevity in your answer.  0.87. What is the ratio of the Number of enrolments of both sexes of South Asia in 2007 to that in 2009?
Offer a very short reply. 0.95. What is the ratio of the Number of enrolments of both sexes of Azerbaijan in 2007 to that in 2009?
Ensure brevity in your answer.  1.06. What is the ratio of the Number of enrolments of both sexes in Dominican Republic in 2007 to that in 2009?
Provide a short and direct response. 0.99. What is the ratio of the Number of enrolments of both sexes of Mali in 2007 to that in 2009?
Your response must be concise. 0.78. What is the ratio of the Number of enrolments of both sexes in South Asia in 2007 to that in 2010?
Your response must be concise. 0.89. What is the ratio of the Number of enrolments of both sexes in Azerbaijan in 2007 to that in 2010?
Offer a terse response. 1.11. What is the ratio of the Number of enrolments of both sexes of Dominican Republic in 2007 to that in 2010?
Provide a succinct answer. 1.02. What is the ratio of the Number of enrolments of both sexes of Mali in 2007 to that in 2010?
Ensure brevity in your answer.  0.7. What is the ratio of the Number of enrolments of both sexes in South Asia in 2008 to that in 2009?
Your answer should be compact. 0.99. What is the ratio of the Number of enrolments of both sexes in Azerbaijan in 2008 to that in 2009?
Keep it short and to the point. 1.03. What is the ratio of the Number of enrolments of both sexes of Dominican Republic in 2008 to that in 2009?
Your answer should be very brief. 0.97. What is the ratio of the Number of enrolments of both sexes of Mali in 2008 to that in 2009?
Offer a very short reply. 0.89. What is the ratio of the Number of enrolments of both sexes in South Asia in 2008 to that in 2010?
Give a very brief answer. 0.94. What is the ratio of the Number of enrolments of both sexes in Azerbaijan in 2008 to that in 2010?
Your response must be concise. 1.08. What is the ratio of the Number of enrolments of both sexes of Dominican Republic in 2008 to that in 2010?
Your answer should be compact. 1.01. What is the ratio of the Number of enrolments of both sexes of Mali in 2008 to that in 2010?
Provide a succinct answer. 0.81. What is the ratio of the Number of enrolments of both sexes of South Asia in 2009 to that in 2010?
Your response must be concise. 0.94. What is the ratio of the Number of enrolments of both sexes of Azerbaijan in 2009 to that in 2010?
Ensure brevity in your answer.  1.05. What is the ratio of the Number of enrolments of both sexes of Dominican Republic in 2009 to that in 2010?
Your response must be concise. 1.03. What is the ratio of the Number of enrolments of both sexes of Mali in 2009 to that in 2010?
Offer a terse response. 0.9. What is the difference between the highest and the second highest Number of enrolments of both sexes of South Asia?
Make the answer very short. 7.90e+06. What is the difference between the highest and the second highest Number of enrolments of both sexes of Azerbaijan?
Ensure brevity in your answer.  3.00e+04. What is the difference between the highest and the second highest Number of enrolments of both sexes in Dominican Republic?
Make the answer very short. 1.36e+04. What is the difference between the highest and the second highest Number of enrolments of both sexes of Mali?
Give a very brief answer. 7.22e+04. What is the difference between the highest and the lowest Number of enrolments of both sexes of South Asia?
Your answer should be compact. 5.67e+07. What is the difference between the highest and the lowest Number of enrolments of both sexes in Azerbaijan?
Keep it short and to the point. 3.07e+05. What is the difference between the highest and the lowest Number of enrolments of both sexes of Dominican Republic?
Give a very brief answer. 5.09e+05. What is the difference between the highest and the lowest Number of enrolments of both sexes in Mali?
Offer a terse response. 6.37e+05. 